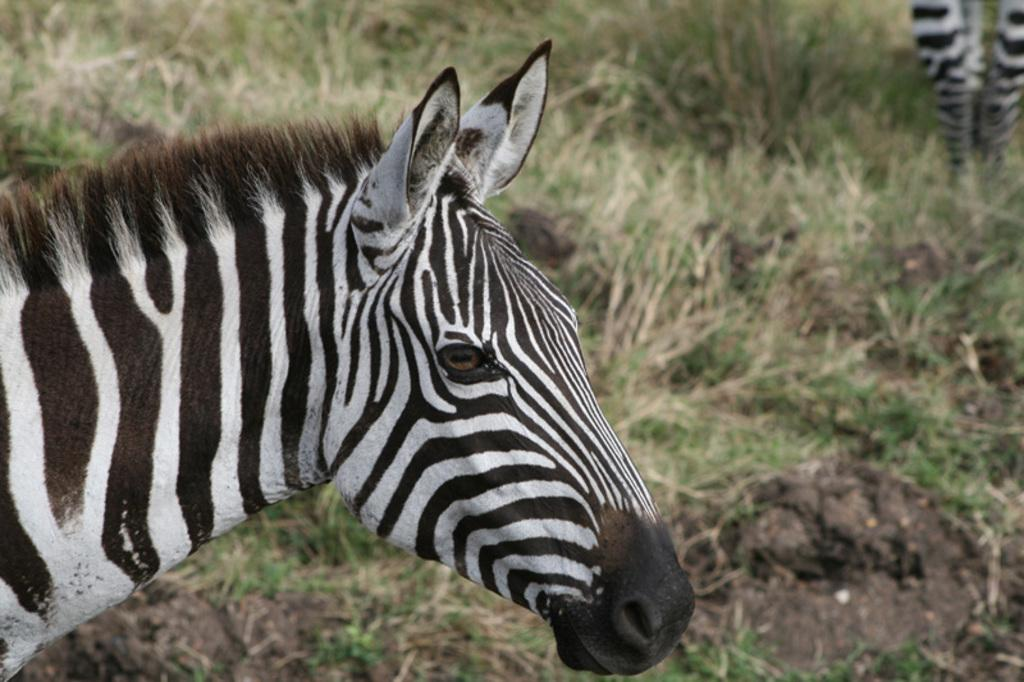What animal is present in the image? There is a zebra in the image. What part of the zebra can be seen in the image? Only the head of the zebra is visible in the image. What type of vegetation is visible in the background of the image? There is grass in the background of the image. Are there any other animals visible in the image? Yes, there is another zebra standing on the grass in the background. What type of knowledge can be gained from the zebra's eye in the image? There is no information about the zebra's eye in the image, so no knowledge can be gained from it. What game is the zebra playing in the image? There is no indication of a game being played in the image; it simply shows a zebra with its head visible. 